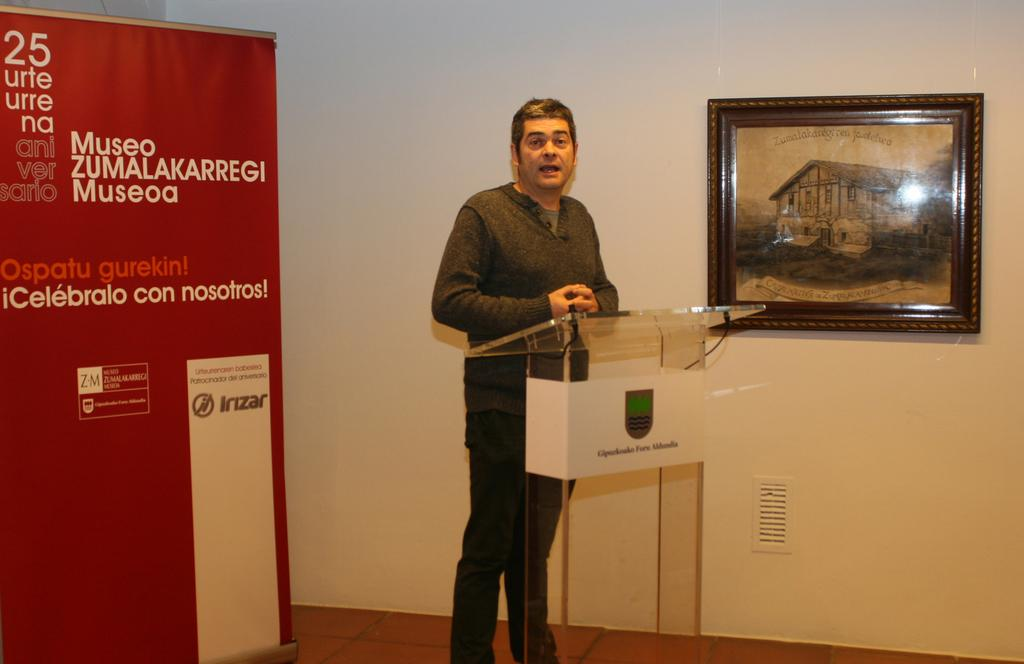What is the person in the image doing near the podium? The person is standing near a podium in the image. What can be seen on the wall in the image? There is a photo frame on the wall in the image. What else is visible in the image besides the person and the photo frame? There is a banner visible in the image. Can you see any docks in the image? There is no dock present in the image. What type of amusement can be seen in the image? There is no amusement depicted in the image; it features a person standing near a podium, a photo frame on the wall, and a banner. 